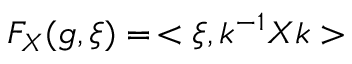<formula> <loc_0><loc_0><loc_500><loc_500>F _ { X } ( g , \xi ) = \, < \xi , k ^ { - 1 } X k ></formula> 